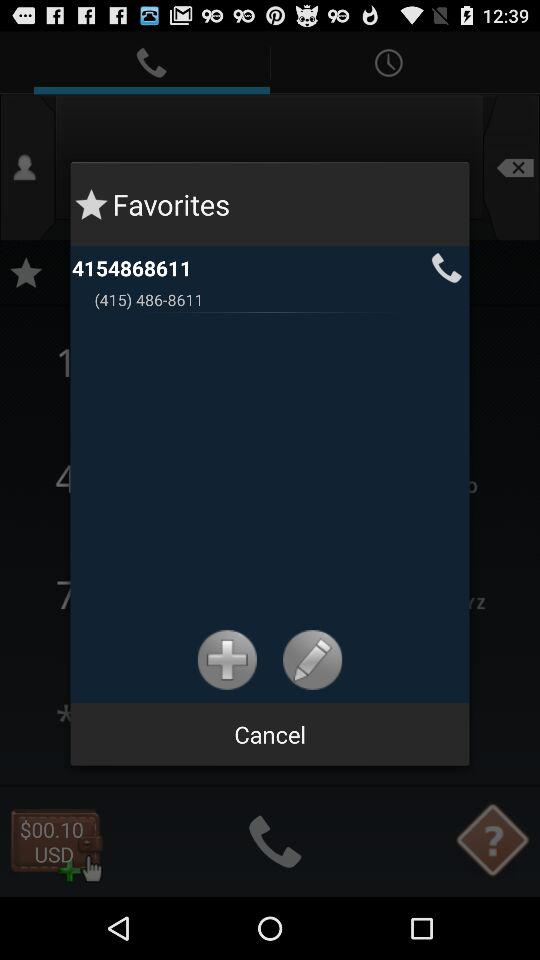What phone number is in "Favorites"? The phone number is 4154868611. 